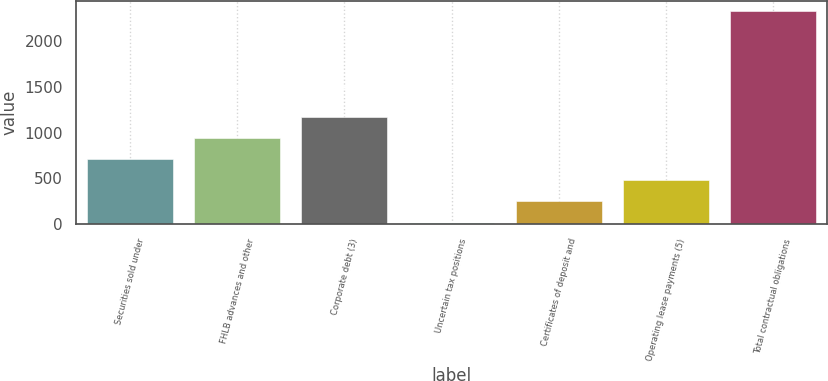Convert chart. <chart><loc_0><loc_0><loc_500><loc_500><bar_chart><fcel>Securities sold under<fcel>FHLB advances and other<fcel>Corporate debt (3)<fcel>Uncertain tax positions<fcel>Certificates of deposit and<fcel>Operating lease payments (5)<fcel>Total contractual obligations<nl><fcel>710.46<fcel>940.38<fcel>1170.3<fcel>20.7<fcel>250.62<fcel>480.54<fcel>2319.9<nl></chart> 